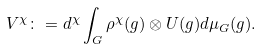<formula> <loc_0><loc_0><loc_500><loc_500>V ^ { \chi } \colon = d ^ { \chi } \int _ { G } \rho ^ { \chi } ( g ) \otimes U ( g ) d \mu _ { G } ( g ) .</formula> 